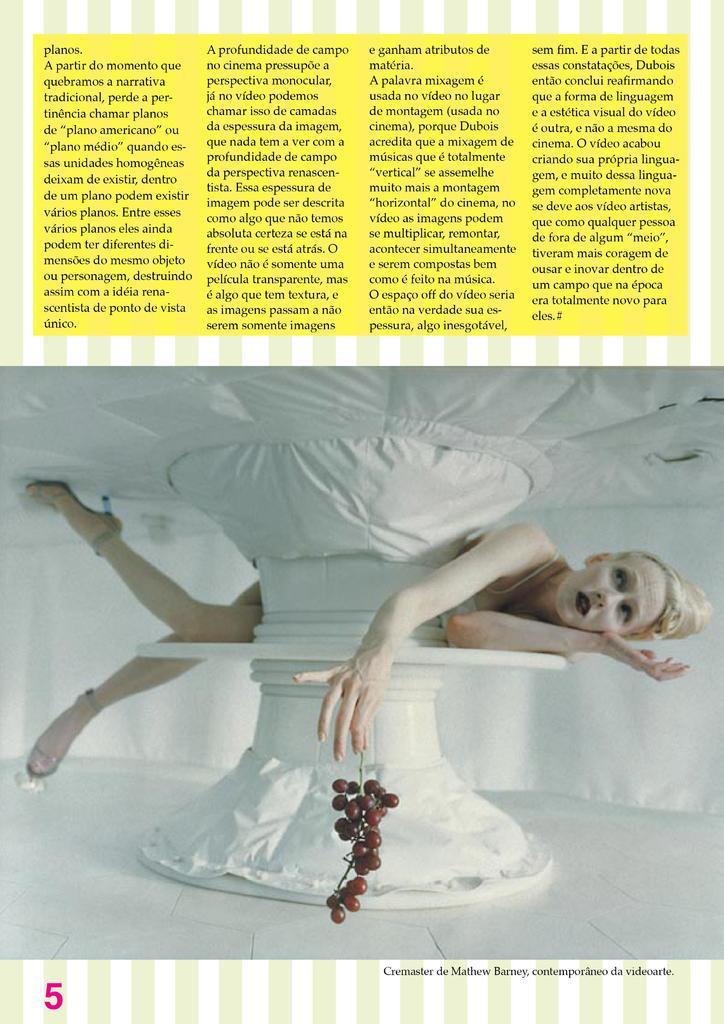Can you describe this image briefly? On top of the image we can see some text and under it there is a picture of a lady and looks like she is lying on a table and she is holding grapes, at the bottom of the image there is some text. 